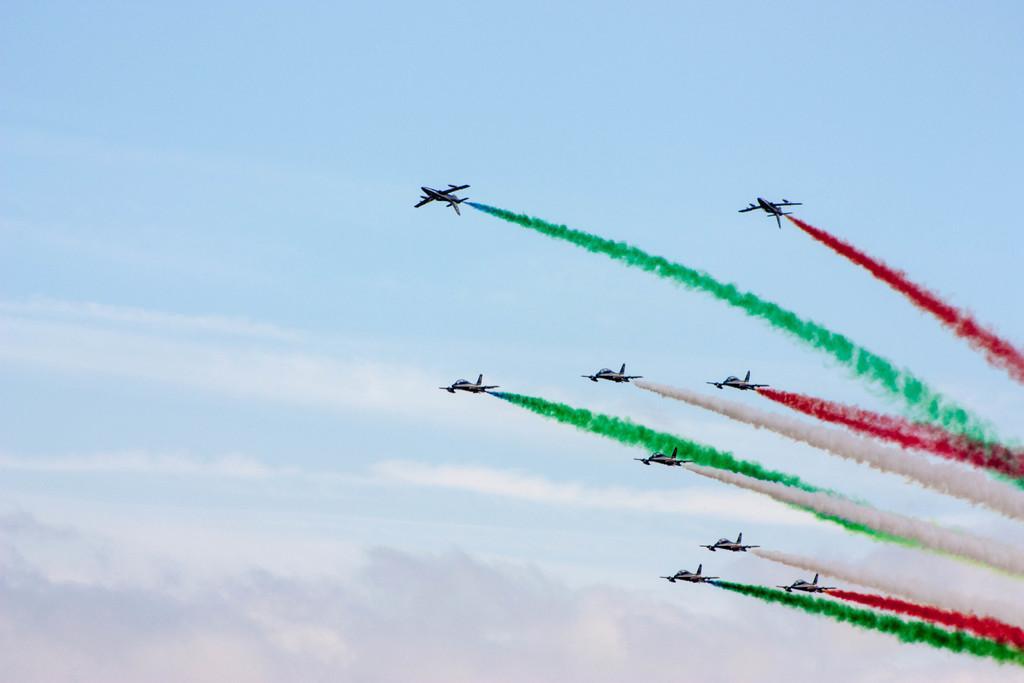In one or two sentences, can you explain what this image depicts? In this picture I can see few jet planes emitting different colors of smoke and I can see blue cloudy sky. 